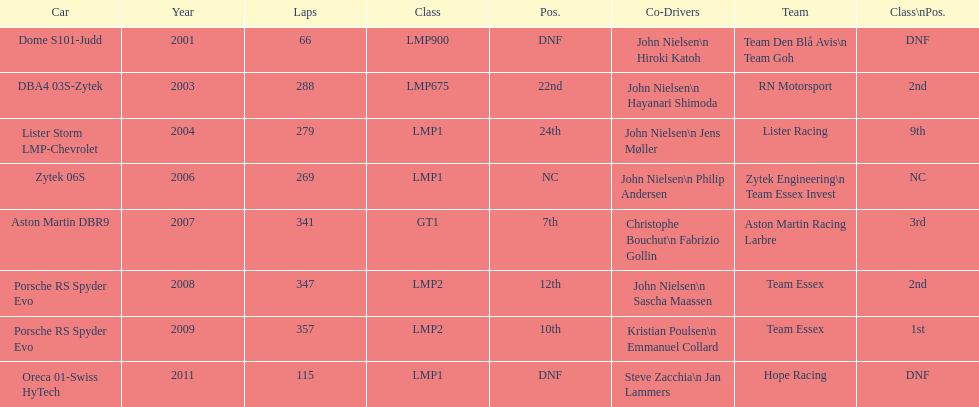What is the amount races that were competed in? 8. 